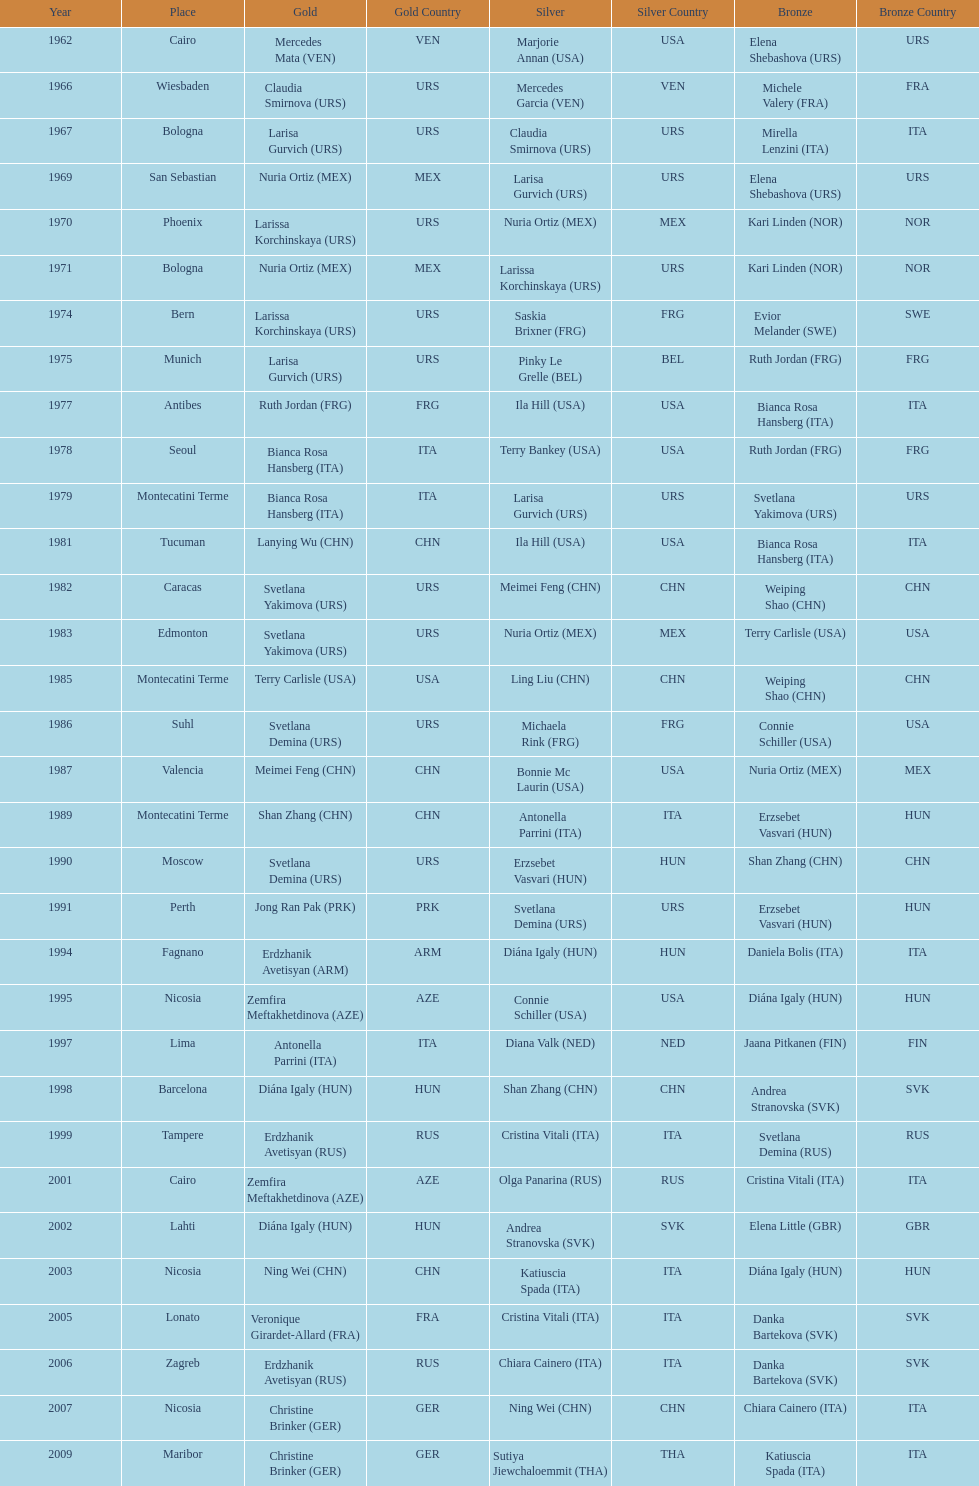What is the total of silver for cairo 0. 